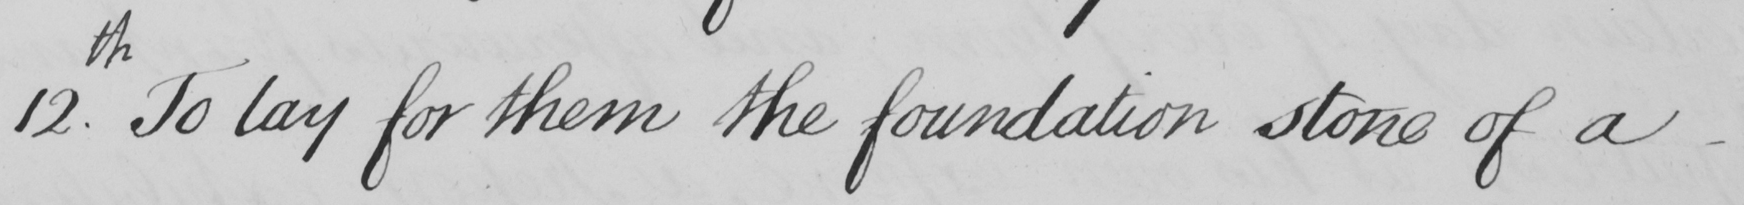Can you tell me what this handwritten text says? 12.th To lay for them the foundation stone of a 